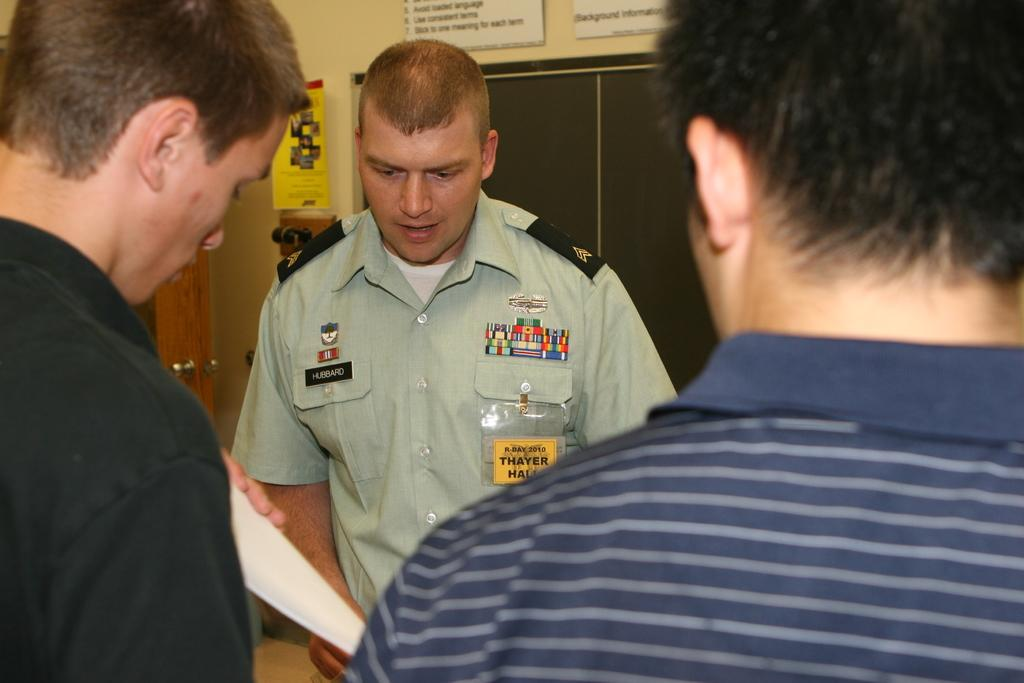Provide a one-sentence caption for the provided image. A man in a uniform with a HUBBARD tag on his shirt is with two other men. 